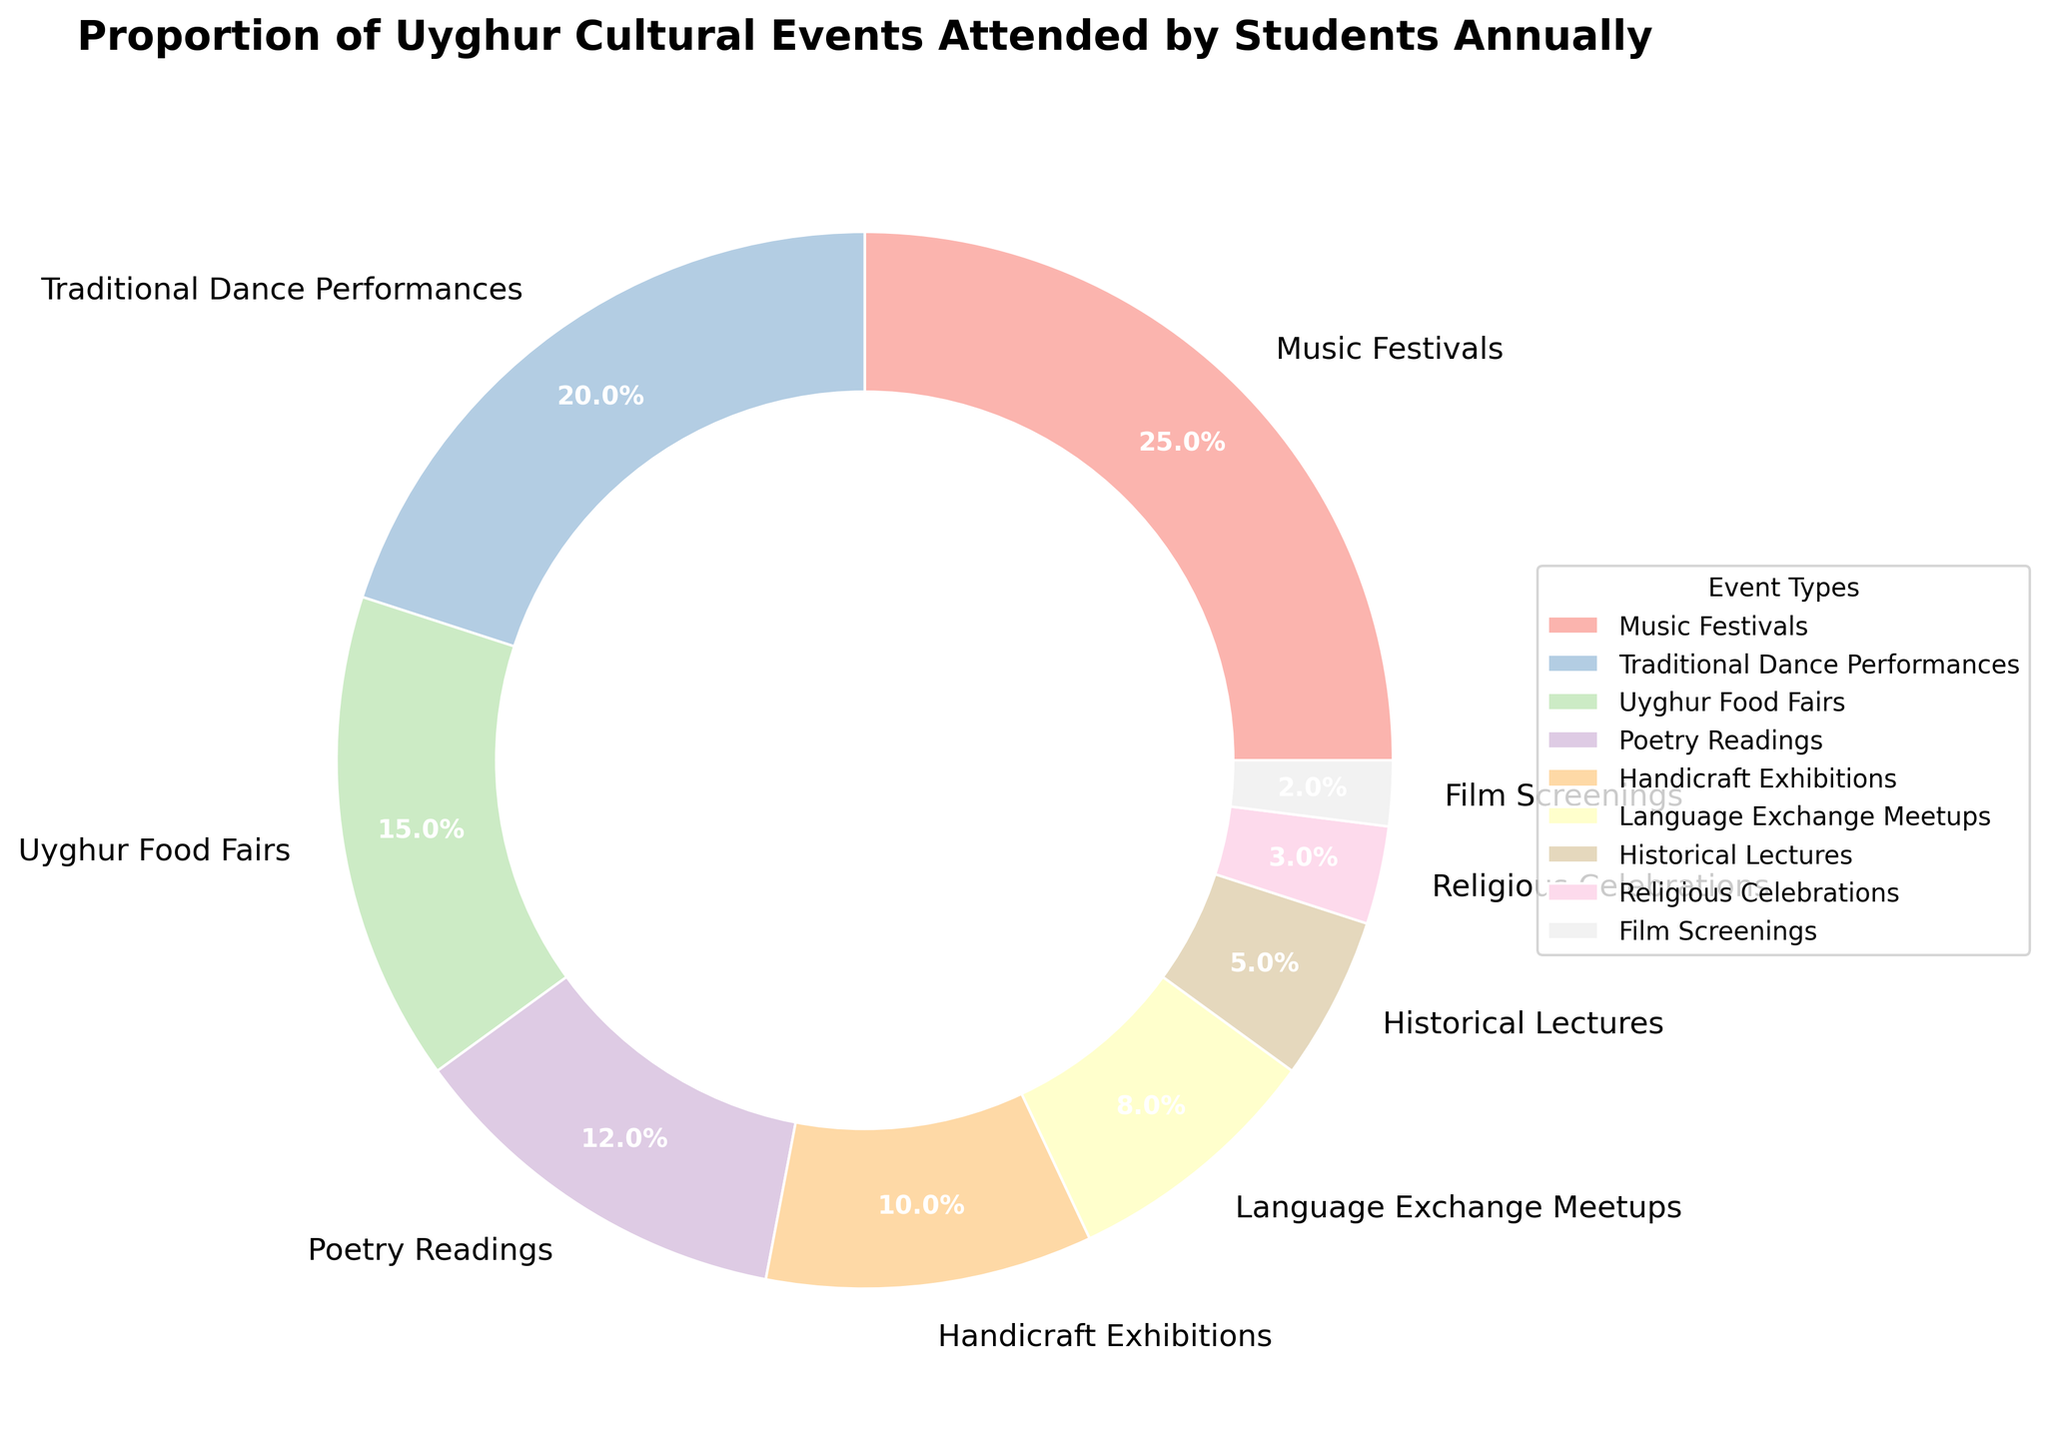What is the largest proportion of cultural events attended by the students annually? The largest segment of the pie chart indicates the event type with the highest attendance. The label shows that Music Festivals occupy 25% of the total.
Answer: Music Festivals Which event type occupies a smaller proportion: Uyghur Food Fairs or Traditional Dance Performances? By comparing the sizes of the segments and checking the labels, Uyghur Food Fairs have 15%, while Traditional Dance Performances have 20%.
Answer: Uyghur Food Fairs What is the combined proportion of Poetry Readings and Handicraft Exhibitions? Adding the individual percentages, Poetry Readings have 12% and Handicraft Exhibitions have 10%. So, the sum is 12% + 10% = 22%.
Answer: 22% Which two event types combined cover exactly 11% of the total? Checking the labels for segments whose sum is 11%, Language Exchange Meetups and Film Screenings fit the criteria with 8% and 2% respectively.
Answer: Language Exchange Meetups and Film Screenings How much more participation is in Traditional Dance Performances compared to Historical Lectures? Subtracting the percentage of Historical Lectures (5%) from Traditional Dance Performances (20%), you get 20% - 5% = 15%.
Answer: 15% What percentage of events are more popular than Handicraft Exhibitions? Identifying segments with a higher percentage than 10% (Handicraft Exhibitions), which are Music Festivals (25%), Traditional Dance Performances (20%), Uyghur Food Fairs (15%), and Poetry Readings (12%). Summed up, 25% + 20% + 15% + 12% = 72%.
Answer: 72% How many event types have an attendance of below 10%? By checking each segment, segments below 10% are Language Exchange Meetups (8%), Historical Lectures (5%), Religious Celebrations (3%), and Film Screenings (2%). So, there are four such event types.
Answer: 4 How much larger is the segment of Uyghur Food Fairs compared to Religious Celebrations? The portion for Uyghur Food Fairs is 15% and for Religious Celebrations is 3%. The difference is 15% - 3% = 12%.
Answer: 12% What is the average proportion of the top three most attended event types? The top three event types are Music Festivals (25%), Traditional Dance Performances (20%), and Uyghur Food Fairs (15%). Calculate the average: (25% + 20% + 15%) / 3 = 60% / 3 = 20%.
Answer: 20% Which event type has the least participation, and what percentage is it? From the pie chart, Film Screenings have the smallest segment with a percentage of 2%.
Answer: Film Screenings, 2% 